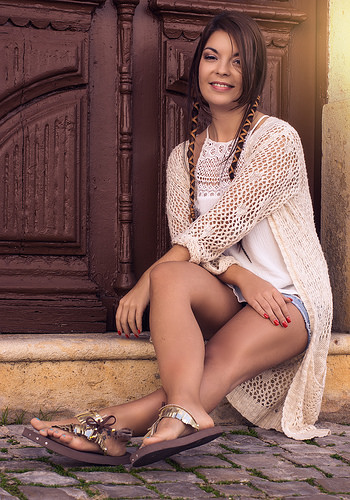<image>
Can you confirm if the woman is behind the wall? No. The woman is not behind the wall. From this viewpoint, the woman appears to be positioned elsewhere in the scene. Is the door in the woman? No. The door is not contained within the woman. These objects have a different spatial relationship. 